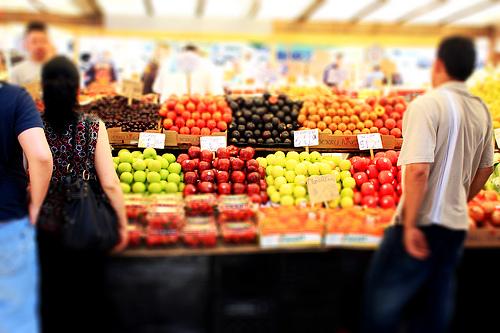How many fruits are displayed?
Give a very brief answer. 10. Are these organic fruits and vegetables?
Be succinct. Yes. How many people are in front of the fruit stand?
Keep it brief. 3. Can you clearly seen anyone's face?
Be succinct. No. 